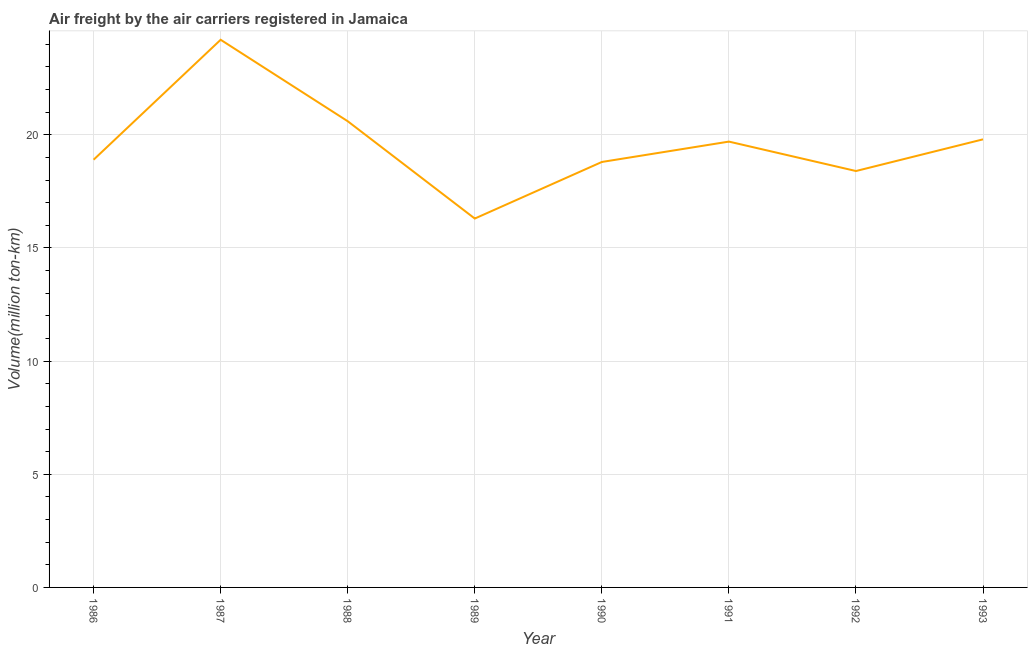What is the air freight in 1991?
Offer a very short reply. 19.7. Across all years, what is the maximum air freight?
Make the answer very short. 24.2. Across all years, what is the minimum air freight?
Keep it short and to the point. 16.3. In which year was the air freight maximum?
Your answer should be very brief. 1987. In which year was the air freight minimum?
Your response must be concise. 1989. What is the sum of the air freight?
Provide a succinct answer. 156.7. What is the difference between the air freight in 1986 and 1987?
Give a very brief answer. -5.3. What is the average air freight per year?
Your response must be concise. 19.59. What is the median air freight?
Make the answer very short. 19.3. What is the ratio of the air freight in 1988 to that in 1991?
Provide a short and direct response. 1.05. What is the difference between the highest and the second highest air freight?
Your response must be concise. 3.6. What is the difference between the highest and the lowest air freight?
Make the answer very short. 7.9. In how many years, is the air freight greater than the average air freight taken over all years?
Give a very brief answer. 4. Does the air freight monotonically increase over the years?
Your response must be concise. No. What is the difference between two consecutive major ticks on the Y-axis?
Your response must be concise. 5. What is the title of the graph?
Provide a short and direct response. Air freight by the air carriers registered in Jamaica. What is the label or title of the X-axis?
Ensure brevity in your answer.  Year. What is the label or title of the Y-axis?
Offer a terse response. Volume(million ton-km). What is the Volume(million ton-km) in 1986?
Provide a short and direct response. 18.9. What is the Volume(million ton-km) of 1987?
Your answer should be very brief. 24.2. What is the Volume(million ton-km) of 1988?
Provide a succinct answer. 20.6. What is the Volume(million ton-km) in 1989?
Provide a short and direct response. 16.3. What is the Volume(million ton-km) in 1990?
Offer a terse response. 18.8. What is the Volume(million ton-km) of 1991?
Give a very brief answer. 19.7. What is the Volume(million ton-km) in 1992?
Your answer should be compact. 18.4. What is the Volume(million ton-km) in 1993?
Keep it short and to the point. 19.8. What is the difference between the Volume(million ton-km) in 1986 and 1987?
Your answer should be very brief. -5.3. What is the difference between the Volume(million ton-km) in 1986 and 1988?
Provide a short and direct response. -1.7. What is the difference between the Volume(million ton-km) in 1986 and 1993?
Keep it short and to the point. -0.9. What is the difference between the Volume(million ton-km) in 1987 and 1990?
Give a very brief answer. 5.4. What is the difference between the Volume(million ton-km) in 1987 and 1991?
Your response must be concise. 4.5. What is the difference between the Volume(million ton-km) in 1989 and 1990?
Provide a succinct answer. -2.5. What is the difference between the Volume(million ton-km) in 1989 and 1993?
Your answer should be very brief. -3.5. What is the difference between the Volume(million ton-km) in 1990 and 1991?
Give a very brief answer. -0.9. What is the difference between the Volume(million ton-km) in 1990 and 1993?
Provide a short and direct response. -1. What is the difference between the Volume(million ton-km) in 1991 and 1992?
Make the answer very short. 1.3. What is the difference between the Volume(million ton-km) in 1991 and 1993?
Your answer should be very brief. -0.1. What is the ratio of the Volume(million ton-km) in 1986 to that in 1987?
Keep it short and to the point. 0.78. What is the ratio of the Volume(million ton-km) in 1986 to that in 1988?
Keep it short and to the point. 0.92. What is the ratio of the Volume(million ton-km) in 1986 to that in 1989?
Offer a very short reply. 1.16. What is the ratio of the Volume(million ton-km) in 1986 to that in 1993?
Your response must be concise. 0.95. What is the ratio of the Volume(million ton-km) in 1987 to that in 1988?
Offer a very short reply. 1.18. What is the ratio of the Volume(million ton-km) in 1987 to that in 1989?
Your answer should be very brief. 1.49. What is the ratio of the Volume(million ton-km) in 1987 to that in 1990?
Give a very brief answer. 1.29. What is the ratio of the Volume(million ton-km) in 1987 to that in 1991?
Your answer should be compact. 1.23. What is the ratio of the Volume(million ton-km) in 1987 to that in 1992?
Ensure brevity in your answer.  1.31. What is the ratio of the Volume(million ton-km) in 1987 to that in 1993?
Provide a succinct answer. 1.22. What is the ratio of the Volume(million ton-km) in 1988 to that in 1989?
Offer a very short reply. 1.26. What is the ratio of the Volume(million ton-km) in 1988 to that in 1990?
Provide a succinct answer. 1.1. What is the ratio of the Volume(million ton-km) in 1988 to that in 1991?
Your answer should be very brief. 1.05. What is the ratio of the Volume(million ton-km) in 1988 to that in 1992?
Provide a short and direct response. 1.12. What is the ratio of the Volume(million ton-km) in 1989 to that in 1990?
Your answer should be very brief. 0.87. What is the ratio of the Volume(million ton-km) in 1989 to that in 1991?
Your answer should be very brief. 0.83. What is the ratio of the Volume(million ton-km) in 1989 to that in 1992?
Offer a very short reply. 0.89. What is the ratio of the Volume(million ton-km) in 1989 to that in 1993?
Offer a very short reply. 0.82. What is the ratio of the Volume(million ton-km) in 1990 to that in 1991?
Offer a very short reply. 0.95. What is the ratio of the Volume(million ton-km) in 1990 to that in 1992?
Your answer should be very brief. 1.02. What is the ratio of the Volume(million ton-km) in 1990 to that in 1993?
Your answer should be compact. 0.95. What is the ratio of the Volume(million ton-km) in 1991 to that in 1992?
Your answer should be compact. 1.07. What is the ratio of the Volume(million ton-km) in 1992 to that in 1993?
Ensure brevity in your answer.  0.93. 